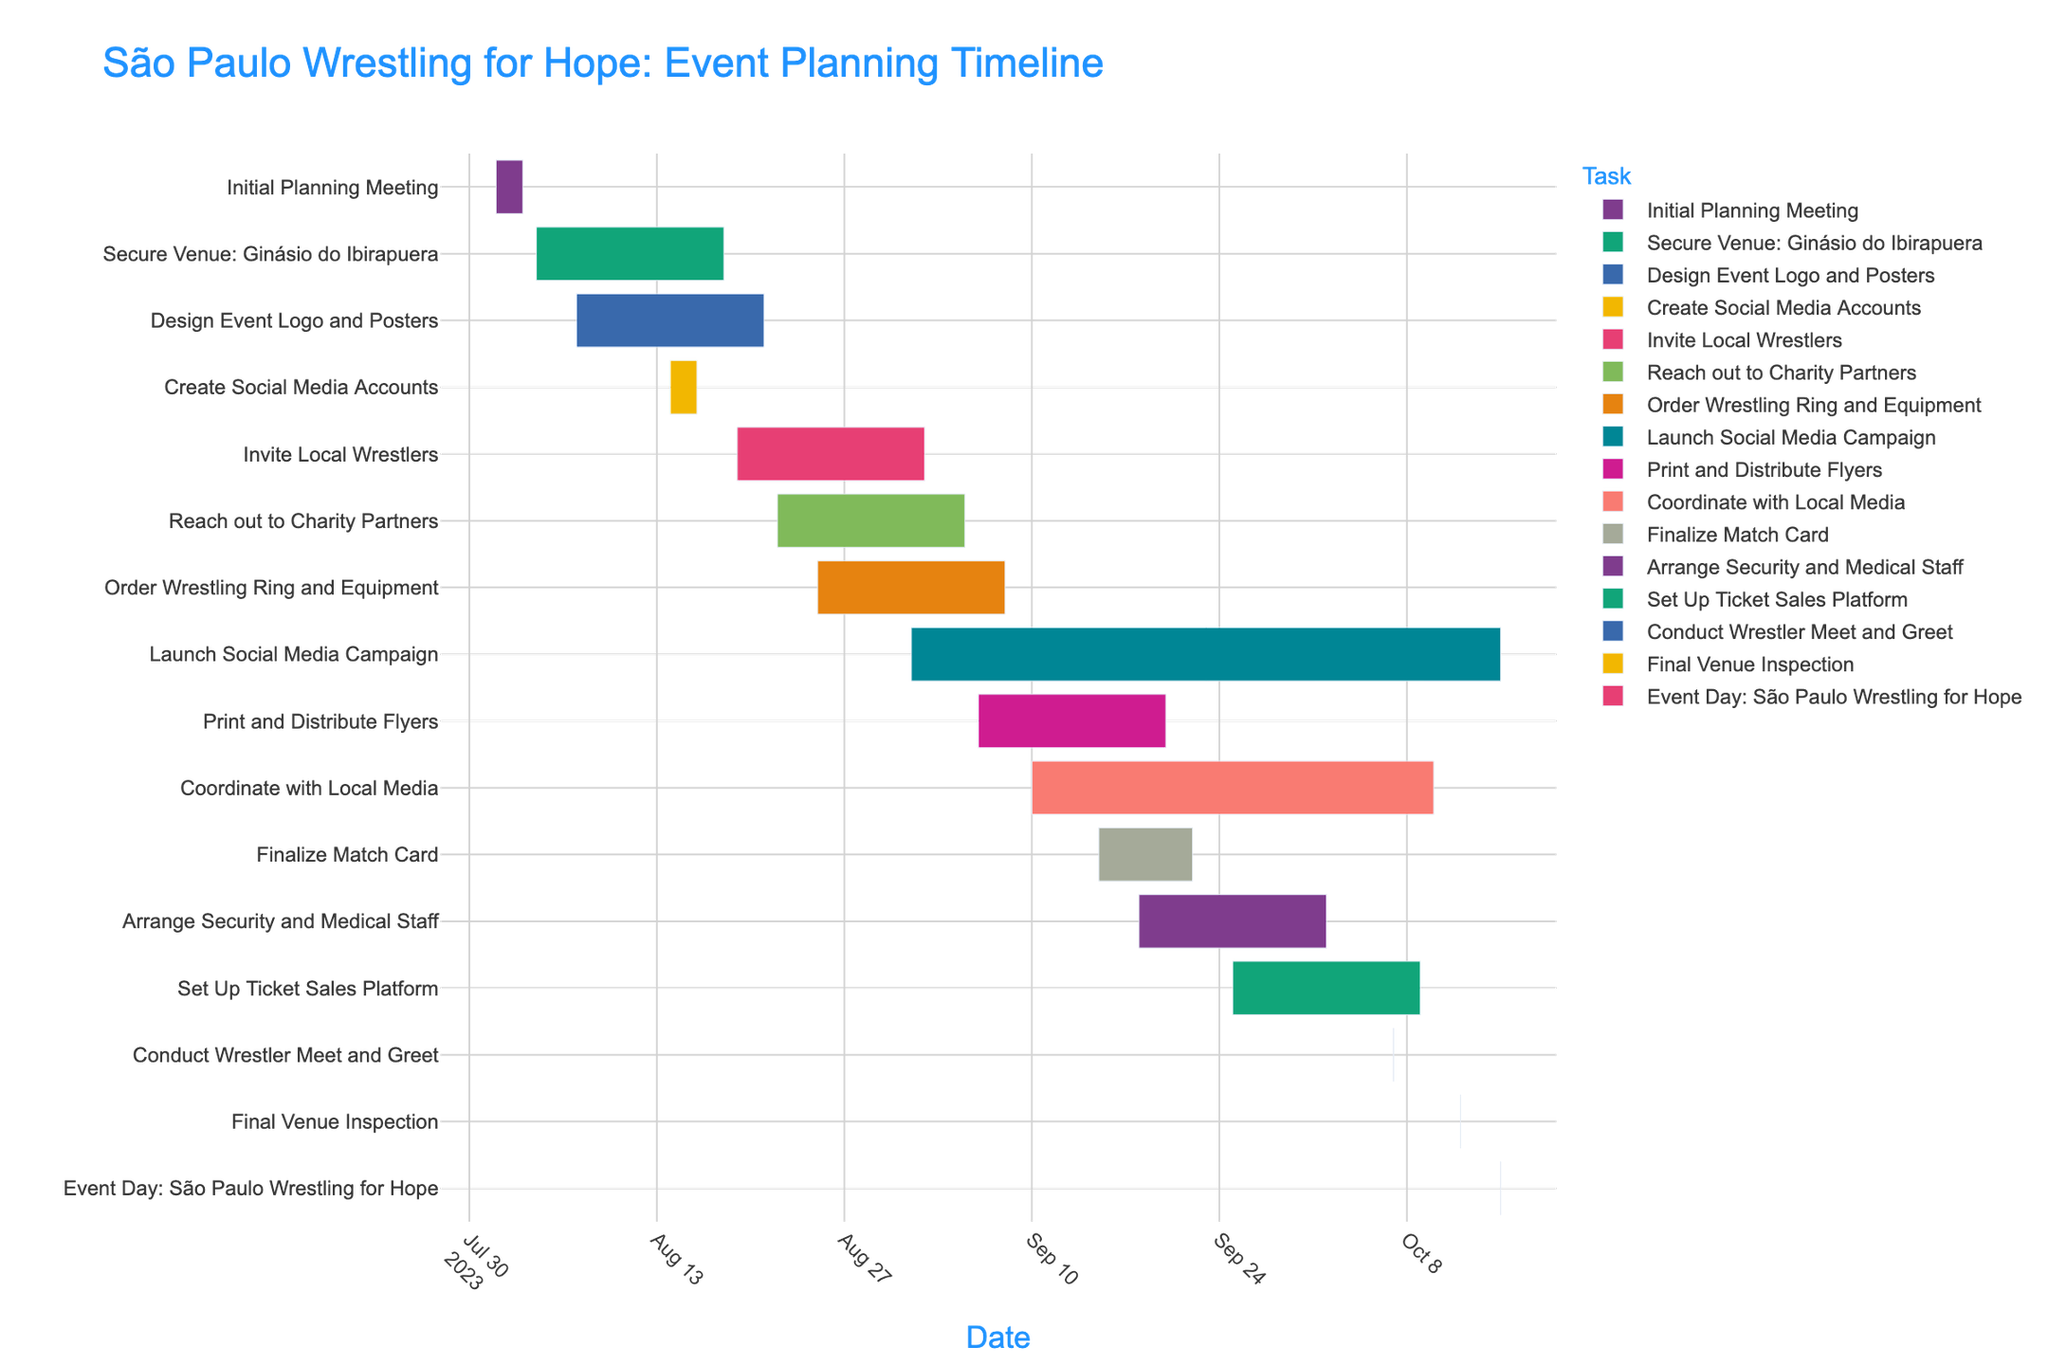What task initiates first on the timeline? By examining the timeline, the task that appears at the very start and furthest to the left is "Initial Planning Meeting."
Answer: Initial Planning Meeting Which tasks overlap during the first half of August? During the first half of August, the tasks visible on the chart that overlap are "Initial Planning Meeting," "Secure Venue: Ginásio do Ibirapuera," and "Design Event Logo and Posters."
Answer: Initial Planning Meeting, Secure Venue: Ginásio do Ibirapuera, Design Event Logo and Posters What is the total duration of the "Secure Venue: Ginásio do Ibirapuera" task? The task begins on August 4 and ends on August 18. To find the total duration, calculate the difference: August 18 - August 4 = 14 days.
Answer: 14 days Which tasks end on the same date as "Finalize Match Card"? Reviewing the timeline, "Finalize Match Card" ends on September 22. The task that also ends on September 22 is "Finalize Match Card" itself—no other task ends on this exact date.
Answer: Finalize Match Card only Which task is scheduled to be completed in the shortest time frame, and how many days does it last? The shortest task can be identified as "Conduct Wrestler Meet and Greet" and "Final Venue Inspection" which occurs on a single day each, making their duration 1 day each.
Answer: Conduct Wrestler Meet and Greet, Final Venue Inspection; 1 day each Compare the durations of "Launch Social Media Campaign" and "Print and Distribute Flyers." Which one is longer and by how many days? "Launch Social Media Campaign" spans from September 1 to October 15, a total of 44 days. "Print and Distribute Flyers" lasts from September 6 to September 20, totaling 14 days. The difference in duration is: 44 days - 14 days = 30 days.
Answer: Launch Social Media Campaign; 30 days longer Which tasks are active (in progress) during the final week before the event day? To find tasks active from October 8 to October 15, check tasks ending within this range: "Coordinate with Local Media," "Set Up Ticket Sales Platform," "Arrange Security and Medical Staff," "Conduct Wrestler Meet and Greet," and "Final Venue Inspection."
Answer: Coordinate with Local Media, Set Up Ticket Sales Platform, Arrange Security and Medical Staff, Conduct Wrestler Meet and Greet, Final Venue Inspection What's the average duration of tasks that start in August? tasks starting in August are: "Initial Planning Meeting", "Secure Venue", "Design Event Logo and Posters", "Create Social Media Accounts", "Invite Local Wrestlers", "Reach out to Charity Partners", and "Order Wrestling Ring and Equipment." Calculate durations (3, 14, 14, 3, 15, 15, 15 days) => (3+14+14+3+15+15+15)/7 = 79/7 ≈ 11.29 days.
Answer: Approximately 11.29 days 